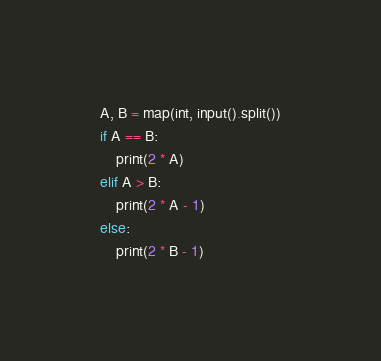<code> <loc_0><loc_0><loc_500><loc_500><_Python_>A, B = map(int, input().split())
if A == B:
    print(2 * A)
elif A > B:
    print(2 * A - 1)
else:
    print(2 * B - 1)</code> 